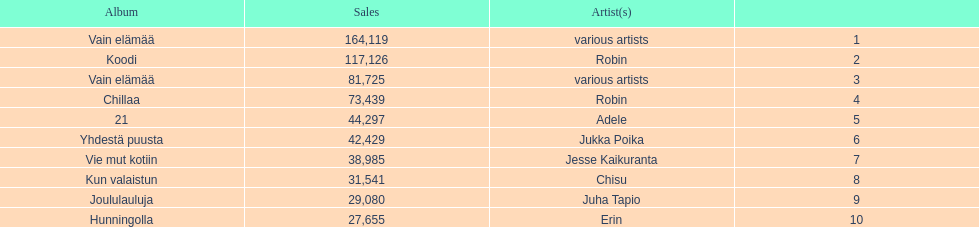What is the total number of sales for the top 10 albums? 650396. 